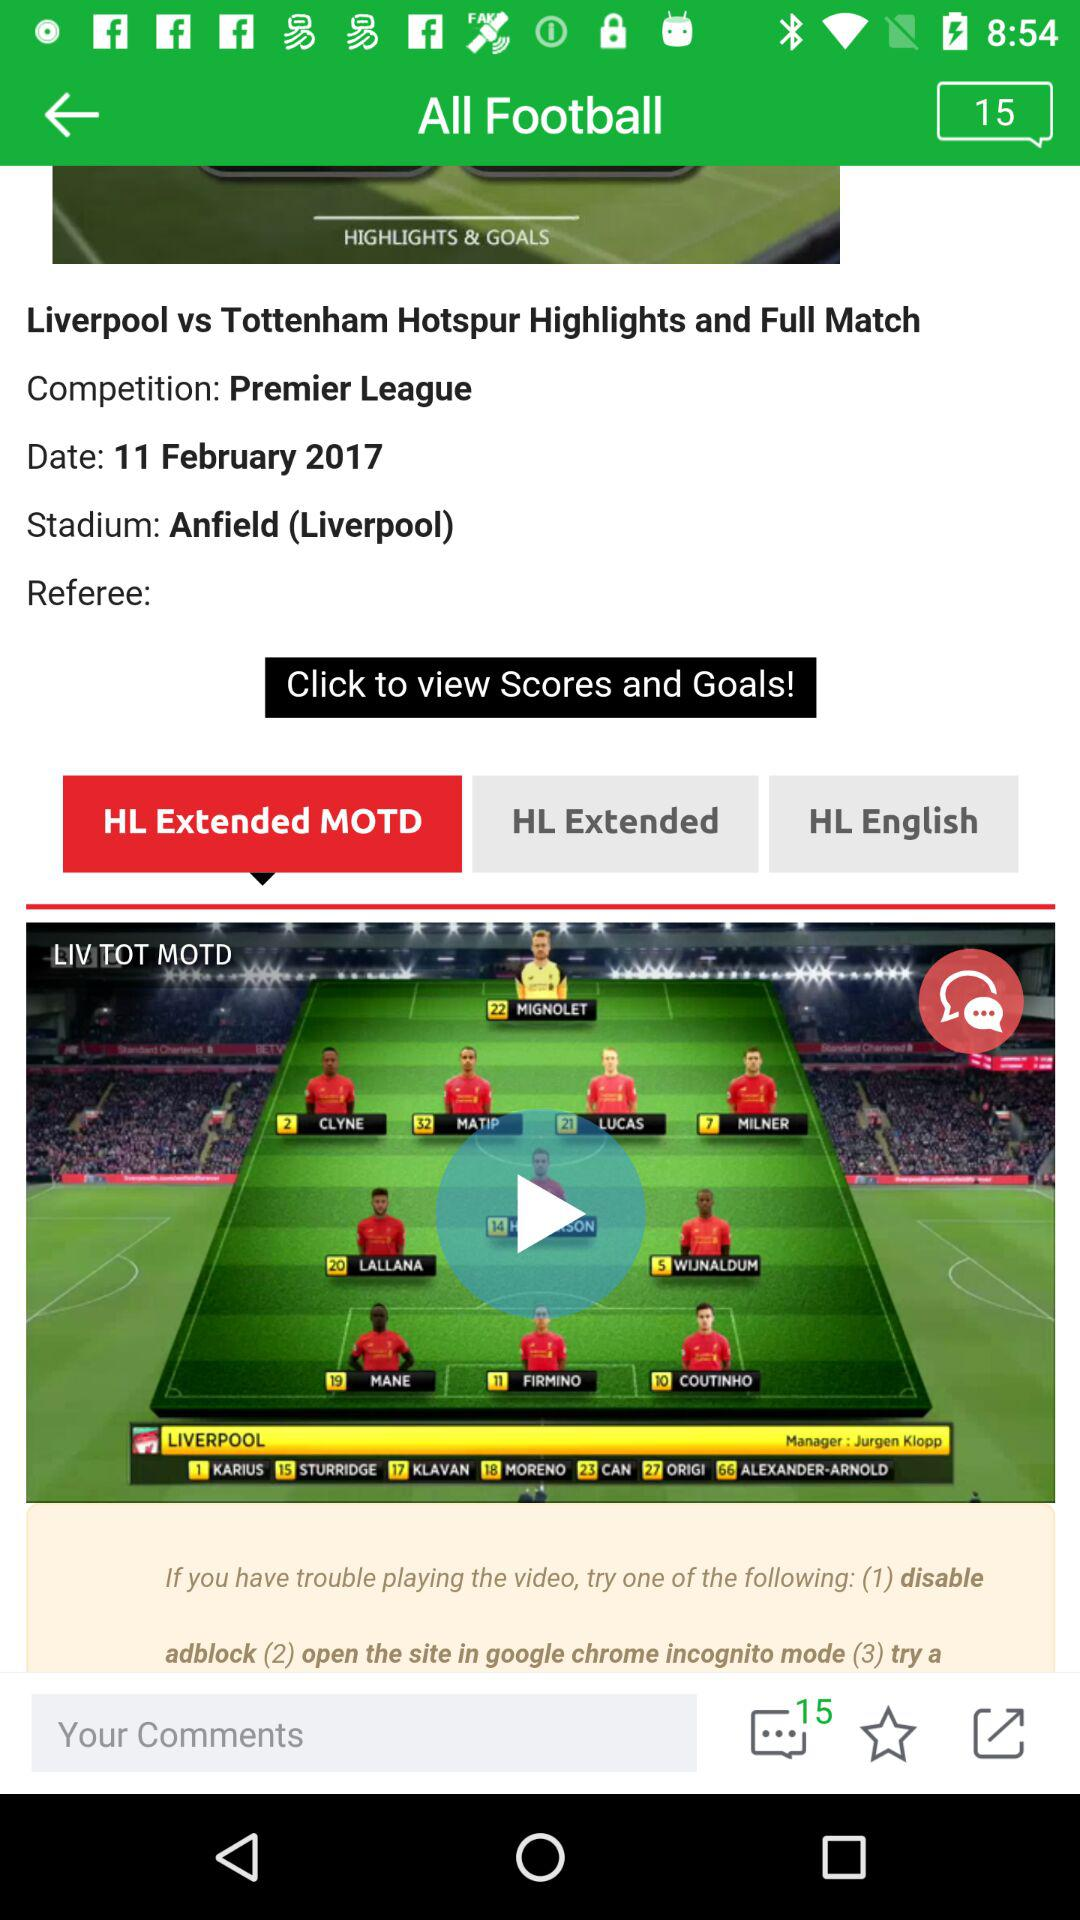What is the name of the stadium? The stadium's name is Anfield (Liverpool). 